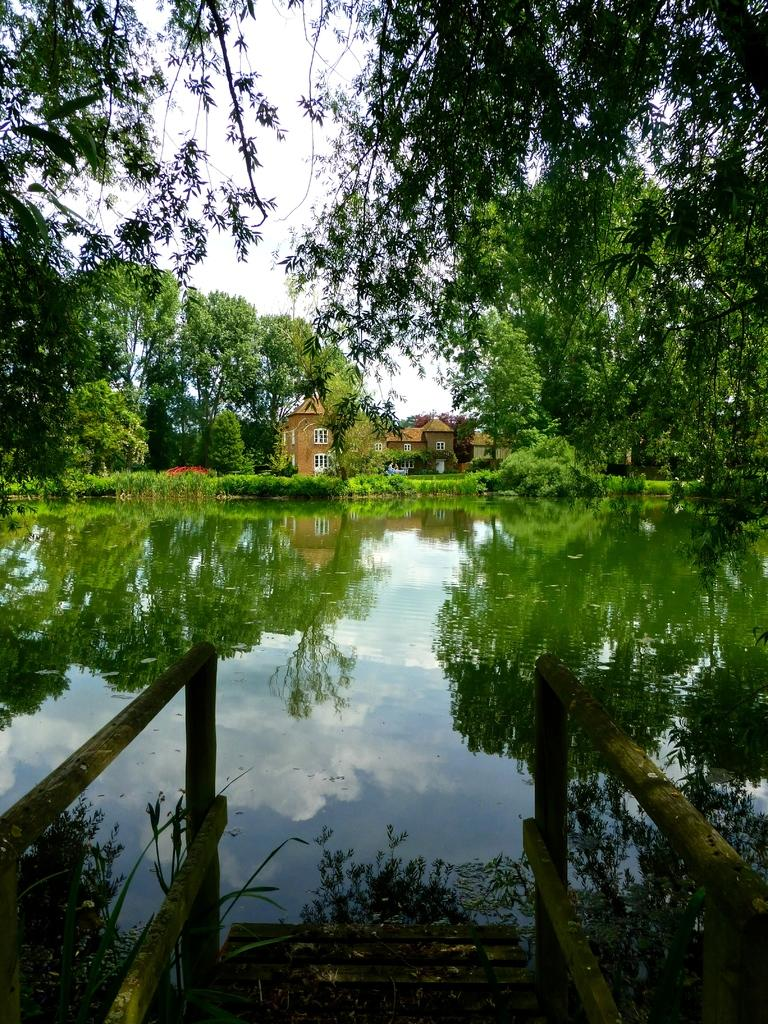What is at the bottom of the image? There is water at the bottom of the image. What structure is located in the middle of the image? There is a building in the middle of the image. What type of vegetation is behind the building? There are trees behind the building. What is visible behind the trees? The sky is visible behind the trees. How many captions are present in the image? There are no captions present in the image. What type of stove can be seen in the image? There is no stove present in the image. 